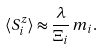Convert formula to latex. <formula><loc_0><loc_0><loc_500><loc_500>\langle S ^ { z } _ { i } \rangle \approx \frac { \lambda } { \Xi _ { i } } \, m _ { i } .</formula> 